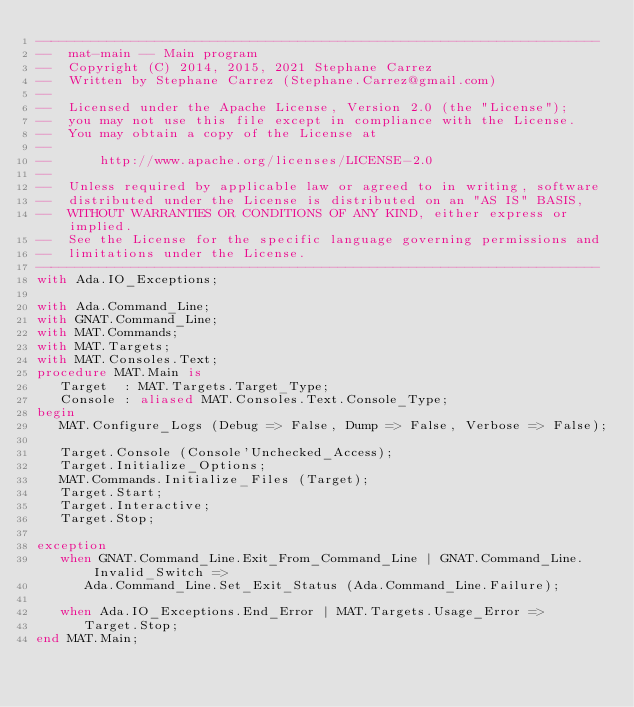Convert code to text. <code><loc_0><loc_0><loc_500><loc_500><_Ada_>-----------------------------------------------------------------------
--  mat-main -- Main program
--  Copyright (C) 2014, 2015, 2021 Stephane Carrez
--  Written by Stephane Carrez (Stephane.Carrez@gmail.com)
--
--  Licensed under the Apache License, Version 2.0 (the "License");
--  you may not use this file except in compliance with the License.
--  You may obtain a copy of the License at
--
--      http://www.apache.org/licenses/LICENSE-2.0
--
--  Unless required by applicable law or agreed to in writing, software
--  distributed under the License is distributed on an "AS IS" BASIS,
--  WITHOUT WARRANTIES OR CONDITIONS OF ANY KIND, either express or implied.
--  See the License for the specific language governing permissions and
--  limitations under the License.
-----------------------------------------------------------------------
with Ada.IO_Exceptions;

with Ada.Command_Line;
with GNAT.Command_Line;
with MAT.Commands;
with MAT.Targets;
with MAT.Consoles.Text;
procedure MAT.Main is
   Target  : MAT.Targets.Target_Type;
   Console : aliased MAT.Consoles.Text.Console_Type;
begin
   MAT.Configure_Logs (Debug => False, Dump => False, Verbose => False);

   Target.Console (Console'Unchecked_Access);
   Target.Initialize_Options;
   MAT.Commands.Initialize_Files (Target);
   Target.Start;
   Target.Interactive;
   Target.Stop;

exception
   when GNAT.Command_Line.Exit_From_Command_Line | GNAT.Command_Line.Invalid_Switch =>
      Ada.Command_Line.Set_Exit_Status (Ada.Command_Line.Failure);

   when Ada.IO_Exceptions.End_Error | MAT.Targets.Usage_Error =>
      Target.Stop;
end MAT.Main;
</code> 